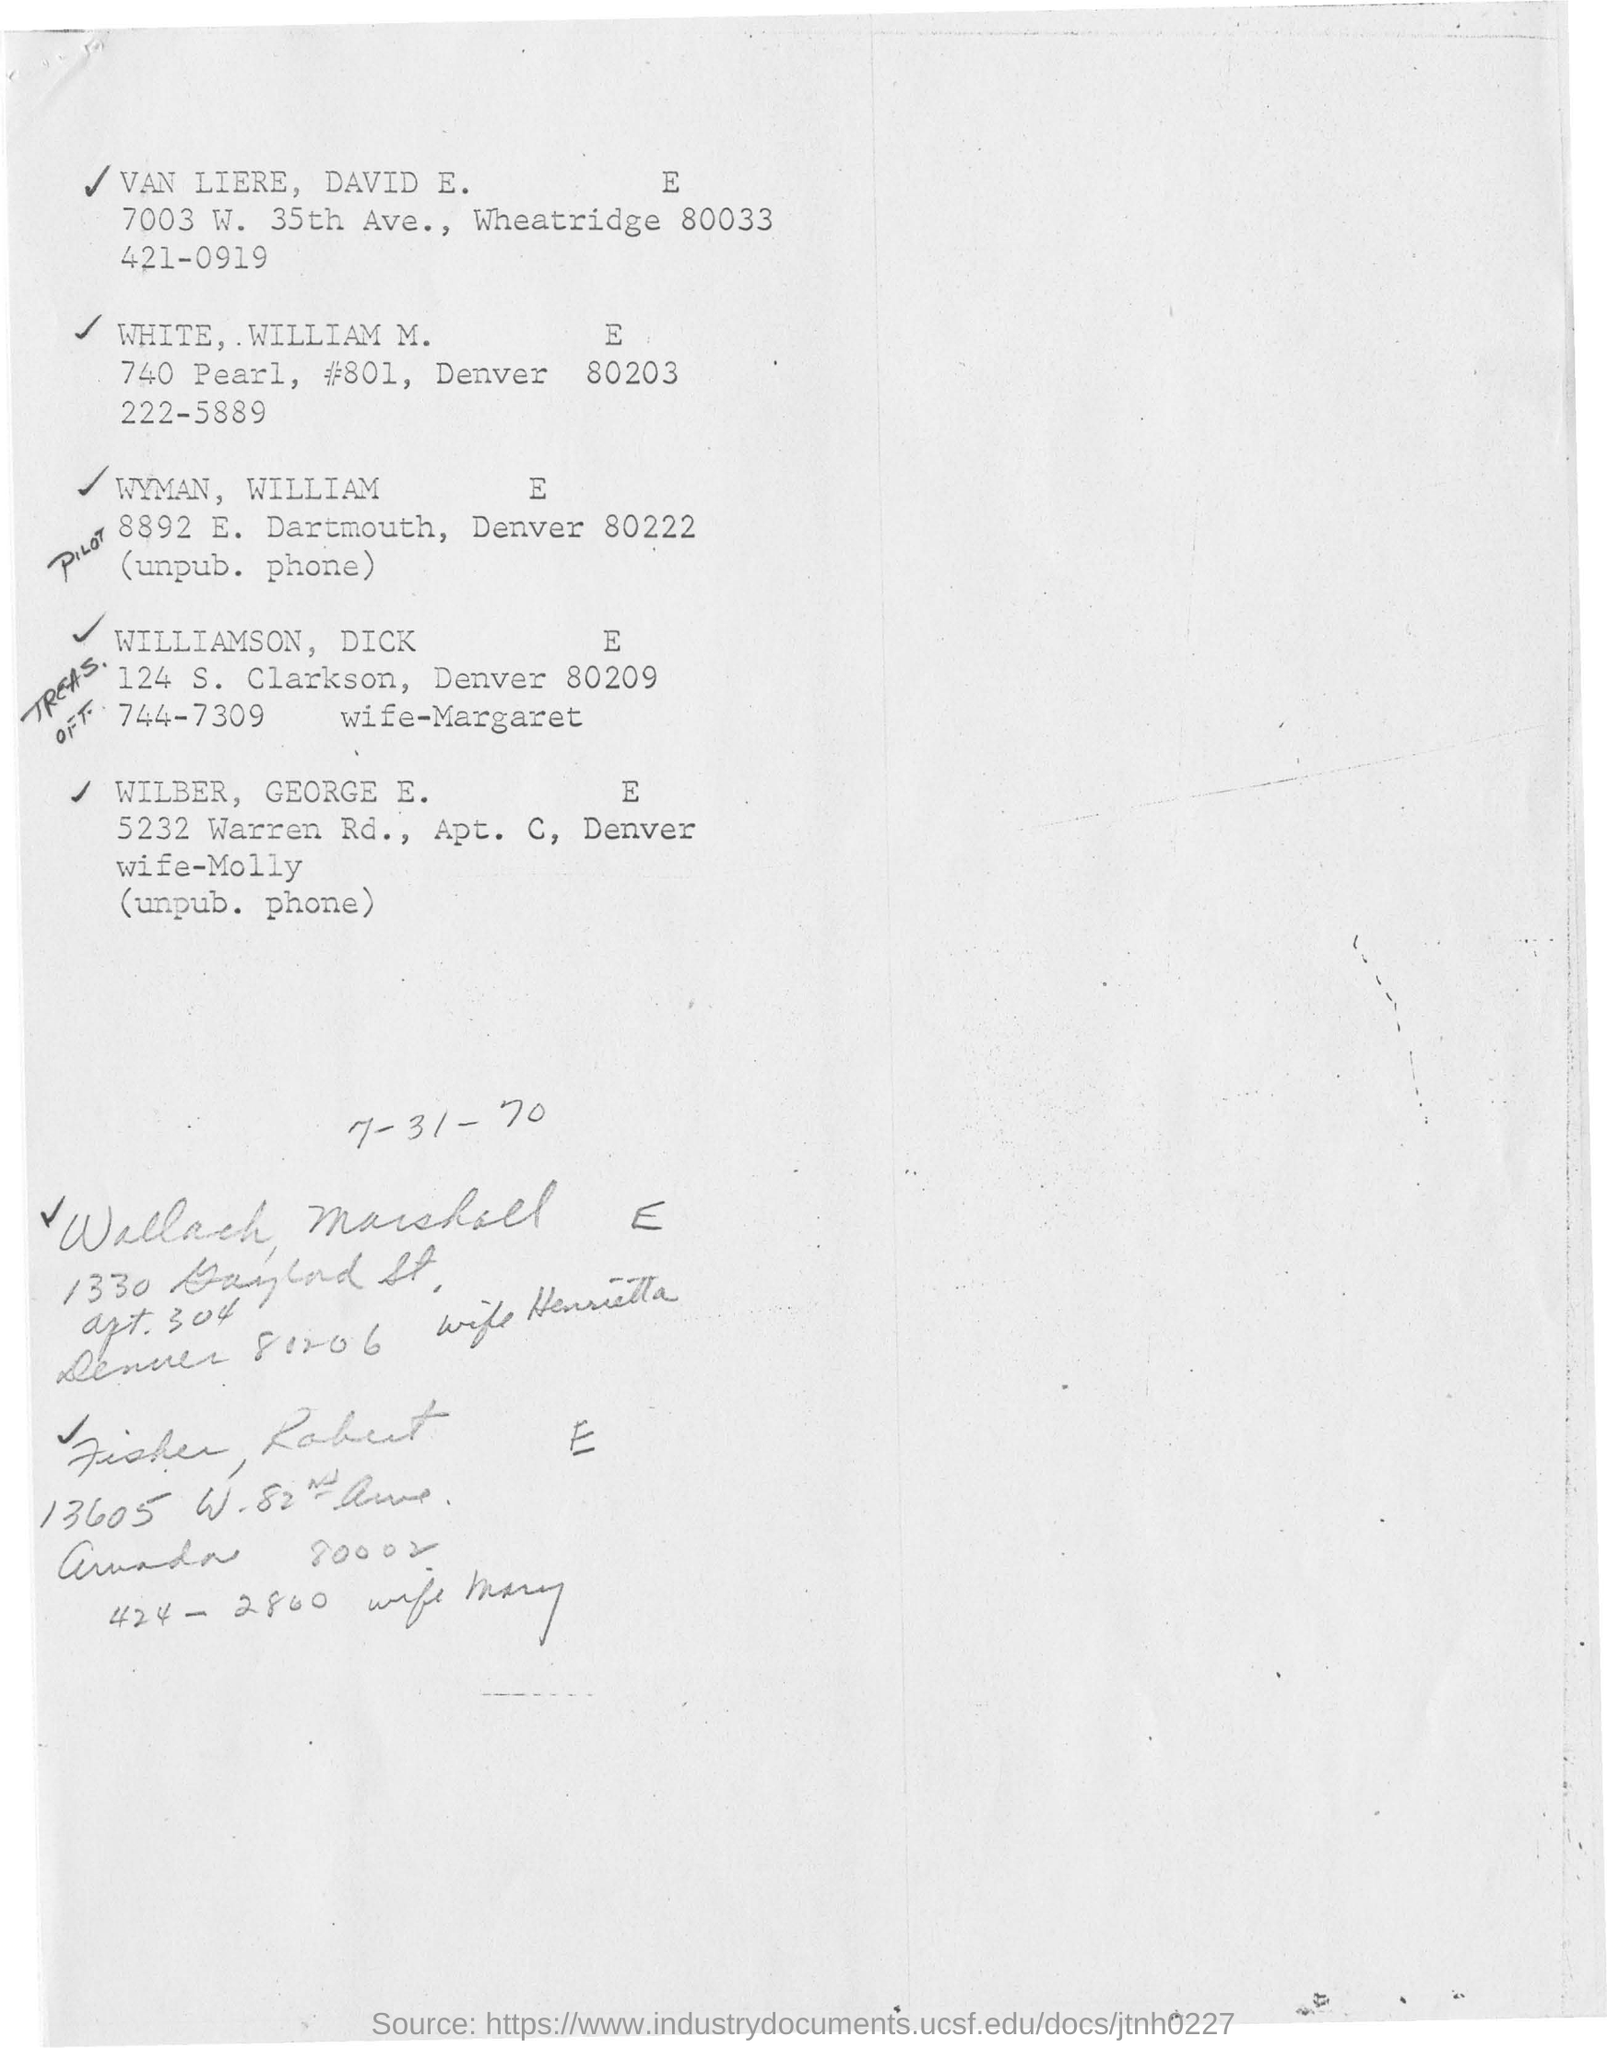List a handful of essential elements in this visual. The address of Wilber, George E. is 5232 Warren Rd., Apt. C, Denver. The first name is VAN LIERE, DAVID E. The second person's address is 740 Pearl, #801, Denver 80203. 